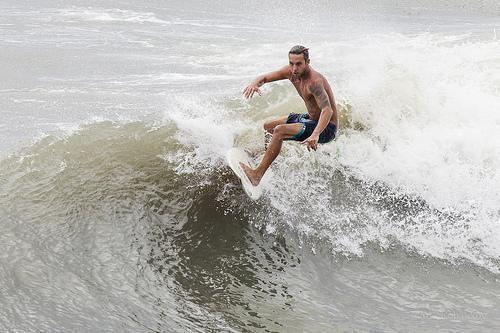How many people are surfing?
Give a very brief answer. 1. 